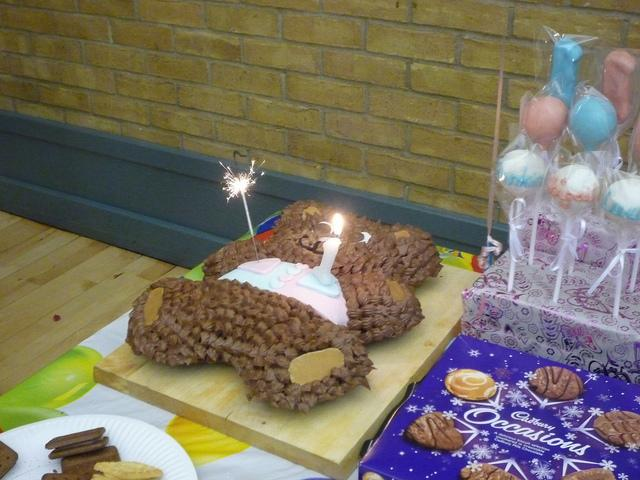What is the cake in the shape of?

Choices:
A) elephant
B) bear
C) cat
D) dog bear 